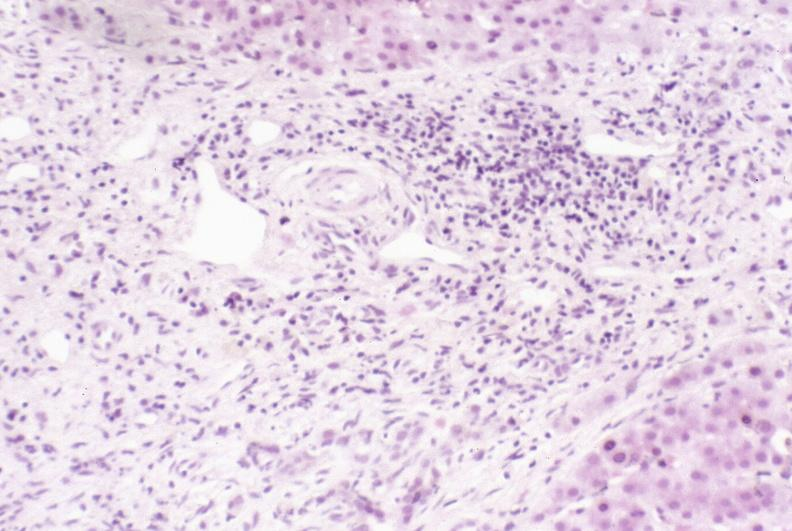s metastatic carcinoma lung present?
Answer the question using a single word or phrase. No 